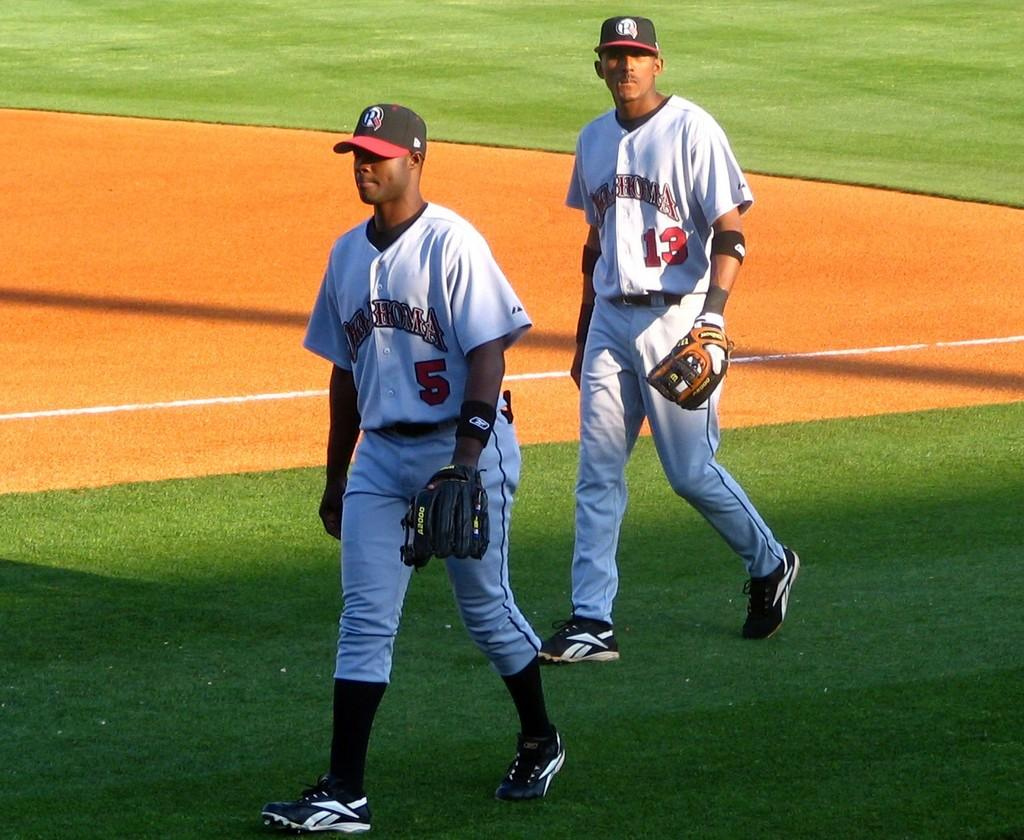<image>
Render a clear and concise summary of the photo. Number 5 and number 13 walk on the baseball field. 